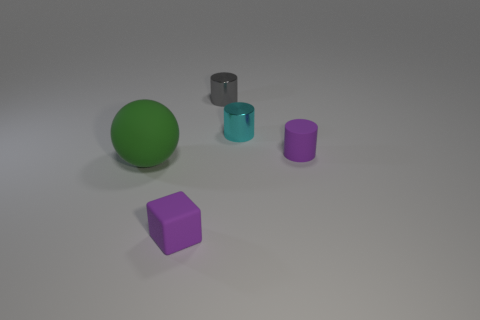Add 4 large matte balls. How many objects exist? 9 Subtract all cubes. How many objects are left? 4 Add 5 large spheres. How many large spheres are left? 6 Add 1 small gray objects. How many small gray objects exist? 2 Subtract 0 green blocks. How many objects are left? 5 Subtract all small purple cylinders. Subtract all tiny brown shiny blocks. How many objects are left? 4 